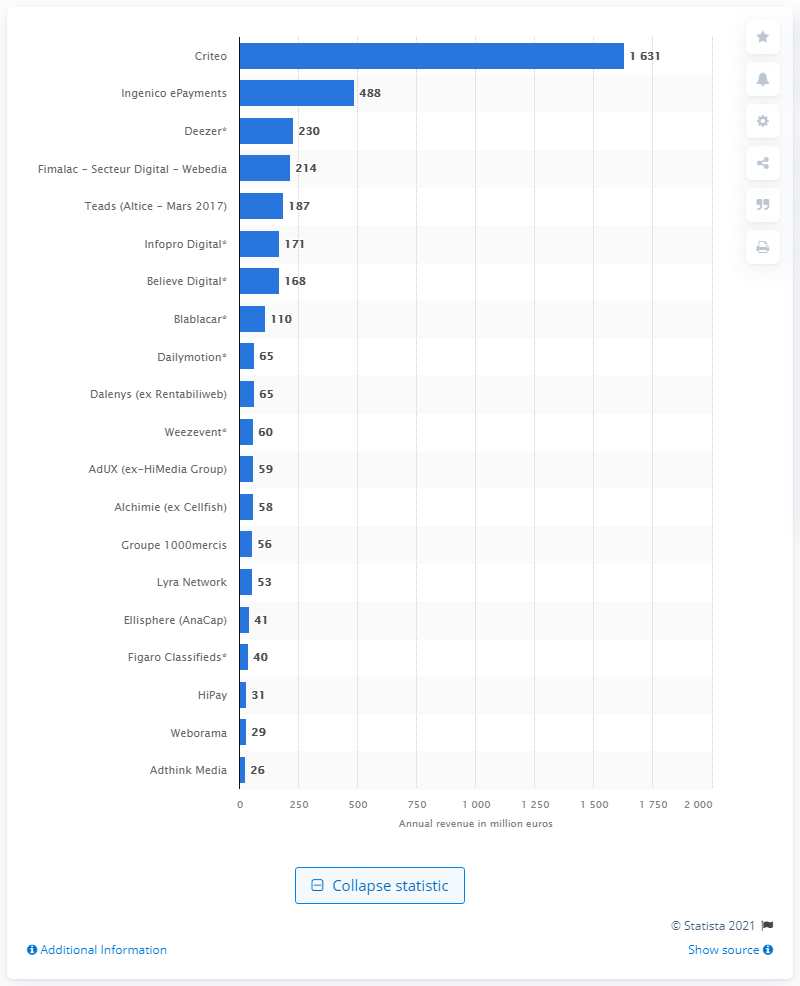Specify some key components in this picture. In 2016, Criteo was the top earning internet services company in France, generating the highest revenue. 